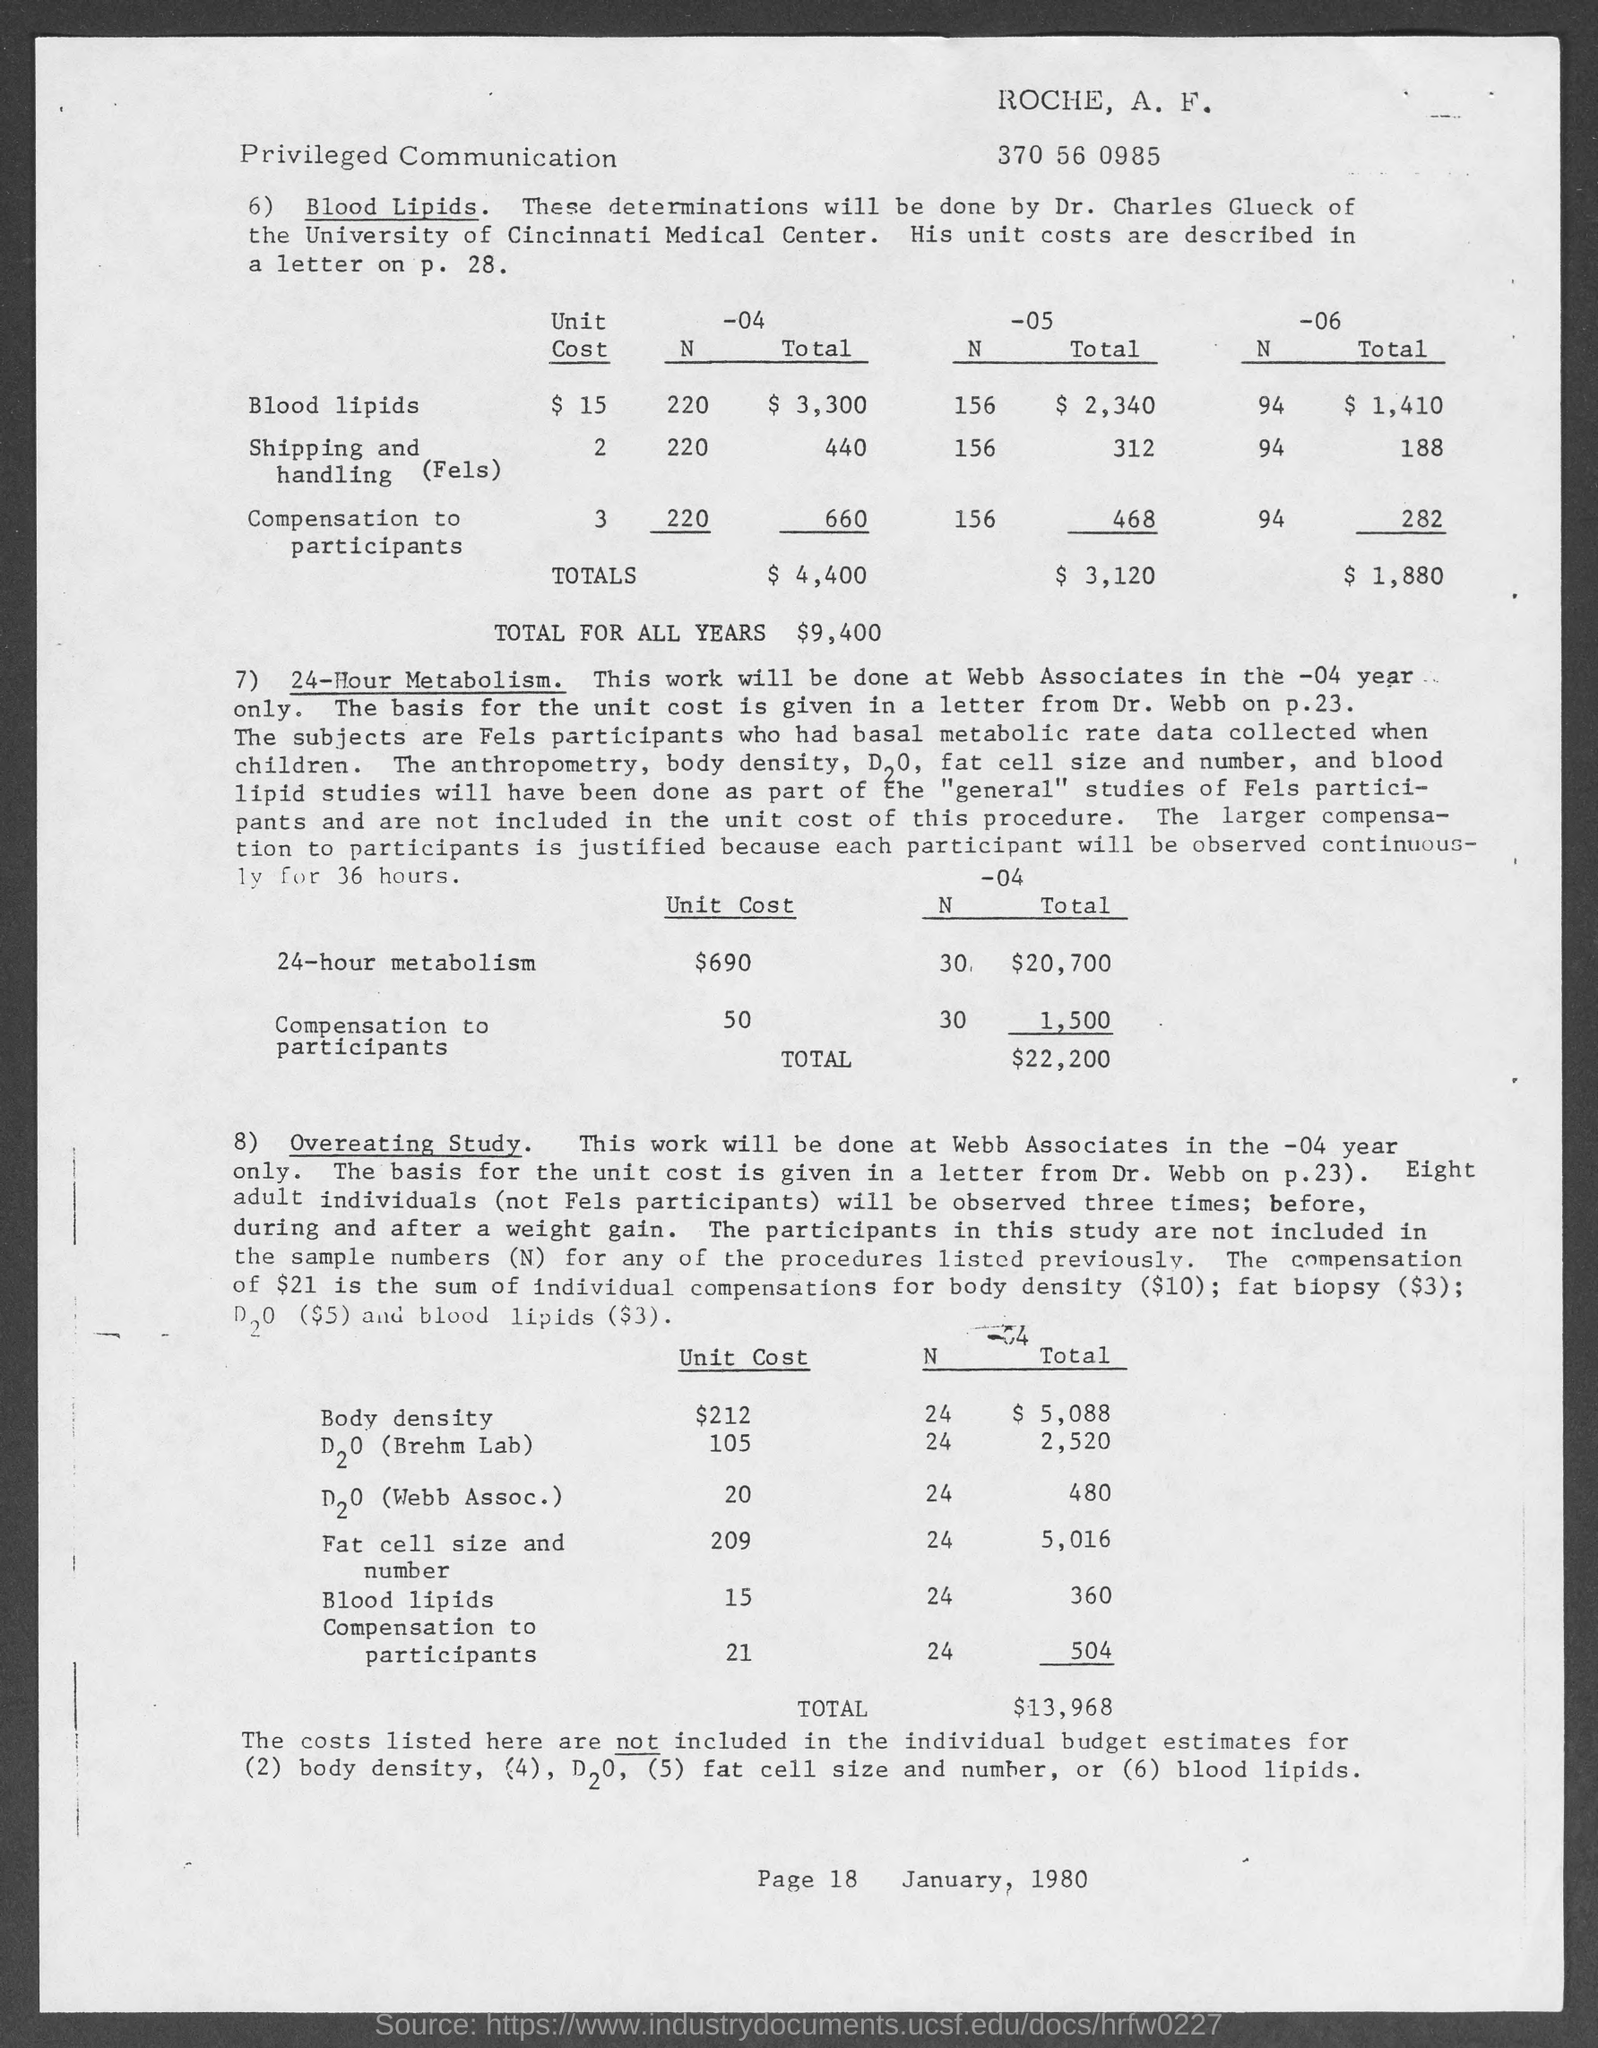What is the Total for all years?
Your answer should be very brief. $9,400. What is the unit cost for 24-hour Metabolism?
Provide a short and direct response. $690. What is the unit cost for Body density?
Make the answer very short. $212. What is the date on the document?
Offer a very short reply. January 1980. What is the Page Number?
Your response must be concise. Page 18. 